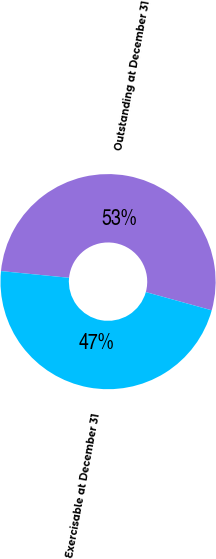Convert chart. <chart><loc_0><loc_0><loc_500><loc_500><pie_chart><fcel>Outstanding at December 31<fcel>Exercisable at December 31<nl><fcel>52.73%<fcel>47.27%<nl></chart> 